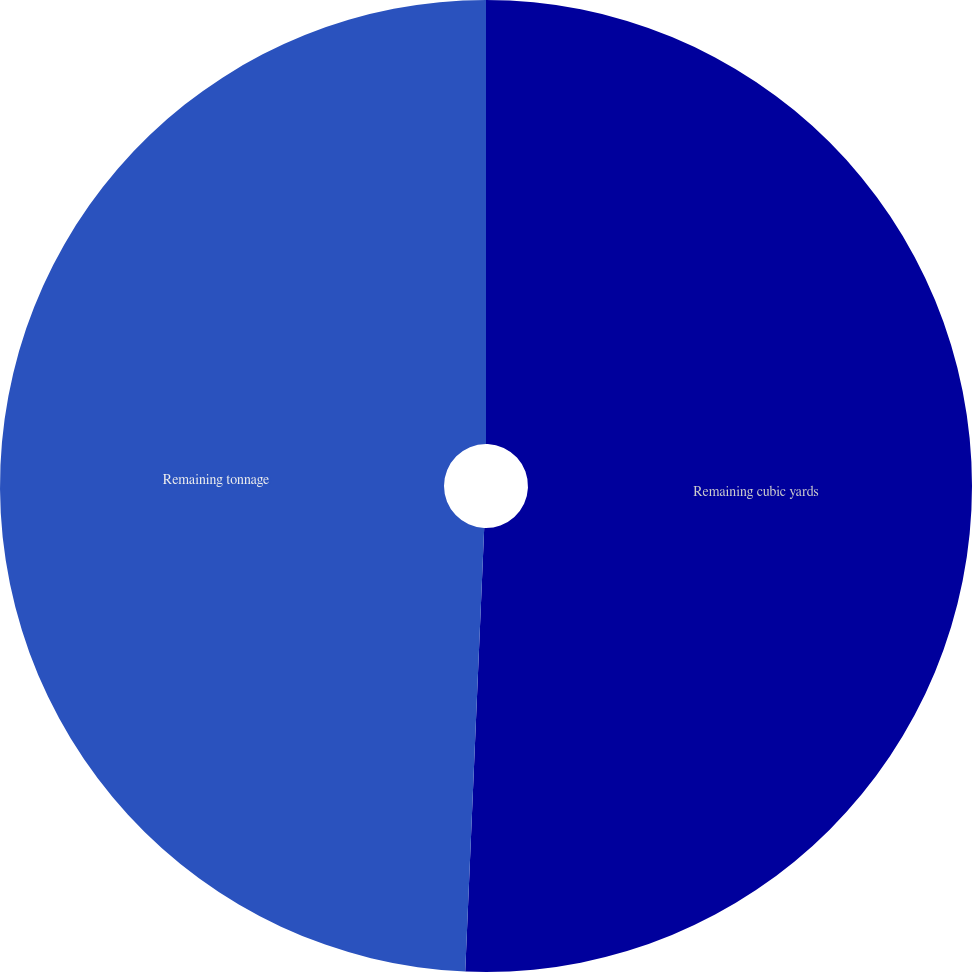Convert chart. <chart><loc_0><loc_0><loc_500><loc_500><pie_chart><fcel>Remaining cubic yards<fcel>Remaining tonnage<nl><fcel>50.68%<fcel>49.32%<nl></chart> 